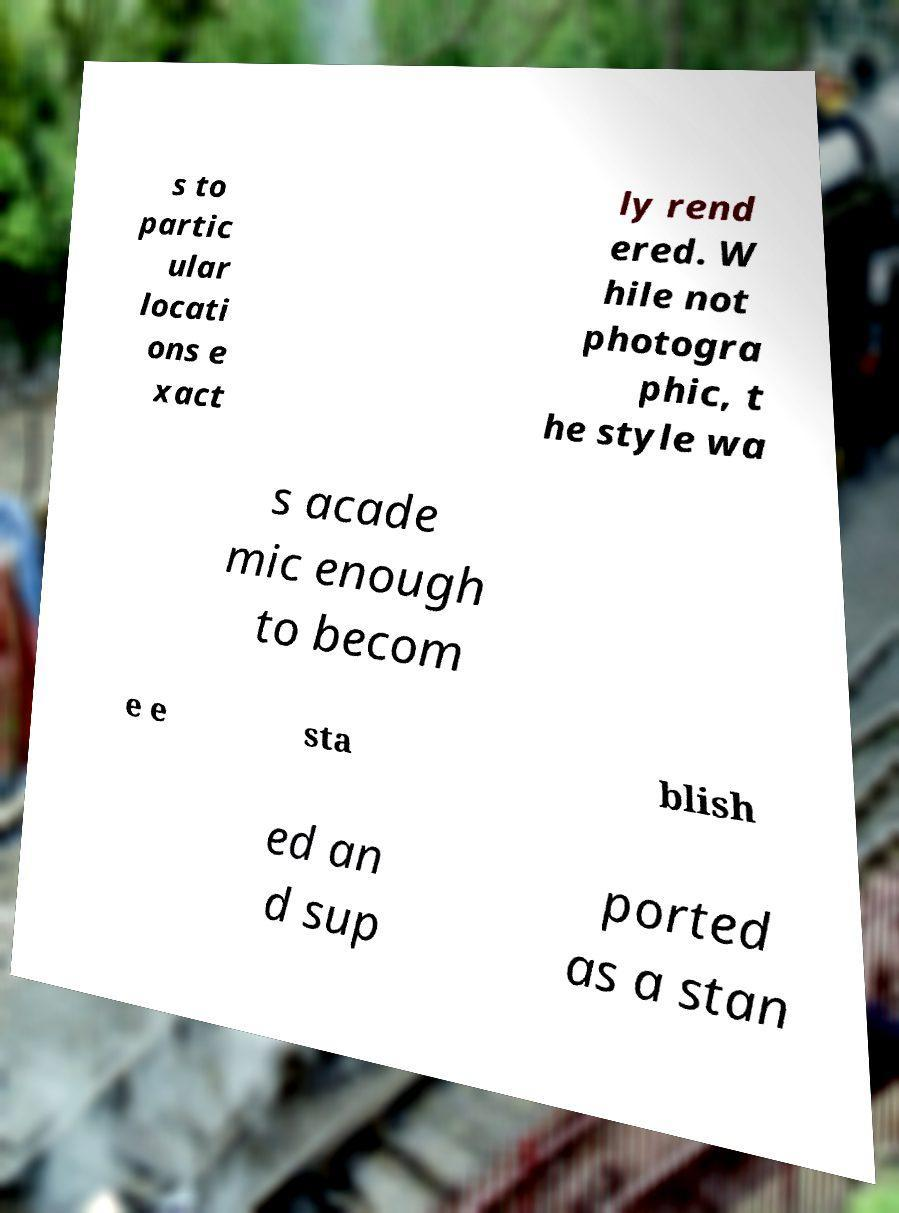What messages or text are displayed in this image? I need them in a readable, typed format. s to partic ular locati ons e xact ly rend ered. W hile not photogra phic, t he style wa s acade mic enough to becom e e sta blish ed an d sup ported as a stan 